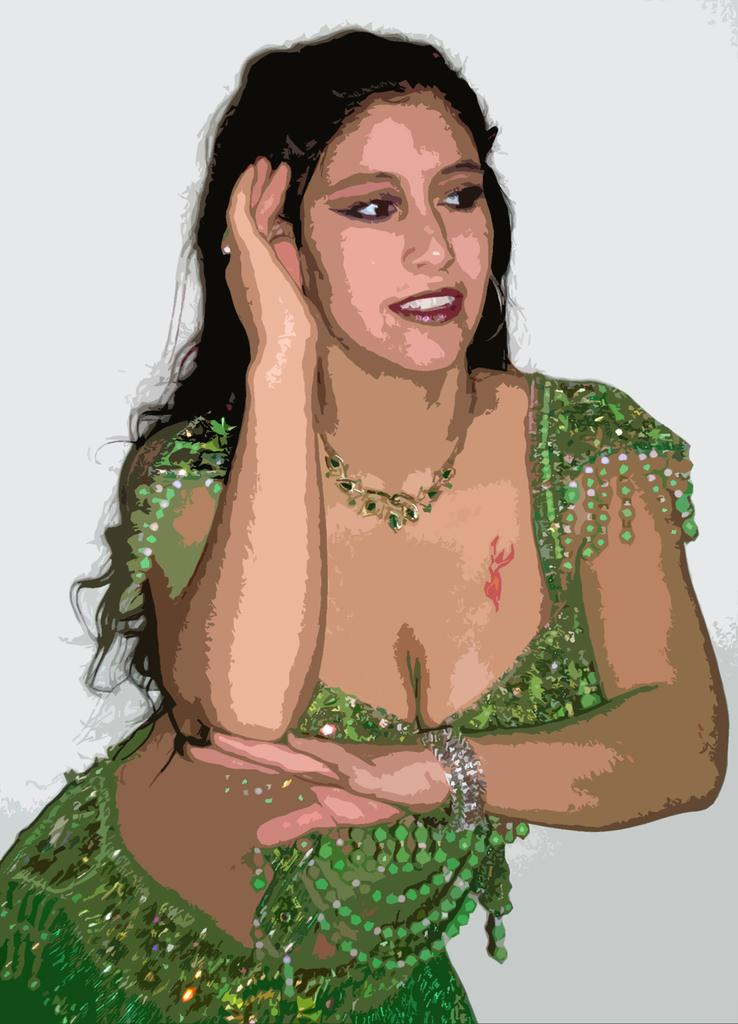What is depicted in the image? There is a painting of a woman in the image. What can be observed about the background of the painting? The background of the painting is white. What type of bath is the woman taking in the image? There is no bath or any indication of a bathing activity in the image; it is a painting of a woman with a white background. 